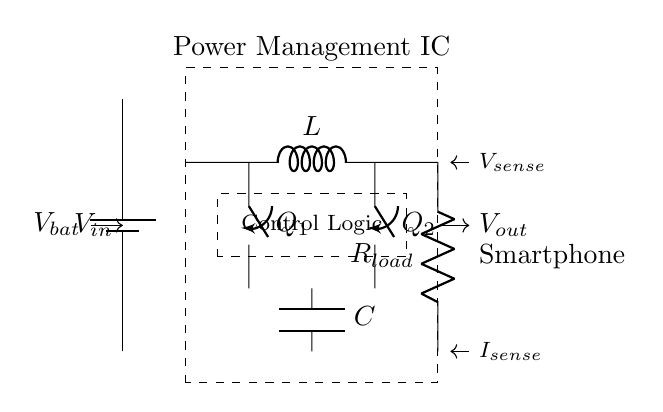What is the function of the Power Management IC? The Power Management IC manages power distribution, optimizing battery usage for longer life.
Answer: manages power distribution What are the components connected to the load? The components connected to the load are the resistor labeled as R_load and the voltage sensing nodes.
Answer: R_load and voltage sensing nodes What is the role of the buck converter in this circuit? The buck converter steps down the input voltage to provide a lower output voltage suitable for the smartphone.
Answer: steps down voltage How many transistors are present in this circuit? There are two transistors, labeled Q1 and Q2, used for switching in the buck converter section.
Answer: two What is the significance of the inductor in the circuit? The inductor stores energy during the conversion process and helps smooth out the output voltage in the power management.
Answer: stores energy What are the two types of sensing involved in this circuit? The two types of sensing are voltage sensing, represented as V_sense, and current sensing, labeled as I_sense.
Answer: voltage and current sensing How does the Control Logic affect the circuit's performance? The Control Logic regulates the operation of the transistors based on feedback from the sensing components, ensuring efficient power conversion.
Answer: regulates operation 